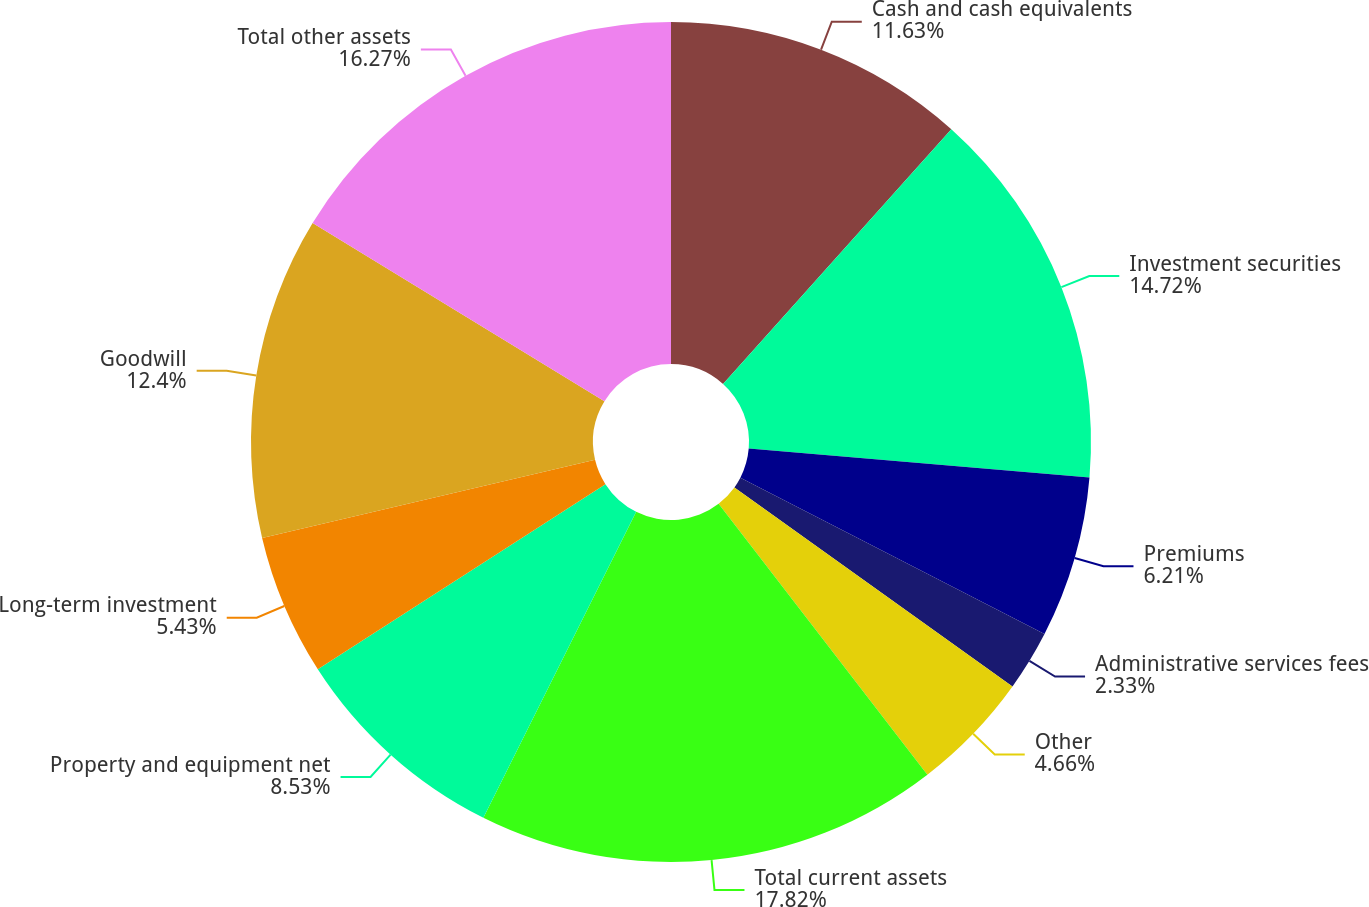Convert chart. <chart><loc_0><loc_0><loc_500><loc_500><pie_chart><fcel>Cash and cash equivalents<fcel>Investment securities<fcel>Premiums<fcel>Administrative services fees<fcel>Other<fcel>Total current assets<fcel>Property and equipment net<fcel>Long-term investment<fcel>Goodwill<fcel>Total other assets<nl><fcel>11.63%<fcel>14.72%<fcel>6.21%<fcel>2.33%<fcel>4.66%<fcel>17.82%<fcel>8.53%<fcel>5.43%<fcel>12.4%<fcel>16.27%<nl></chart> 